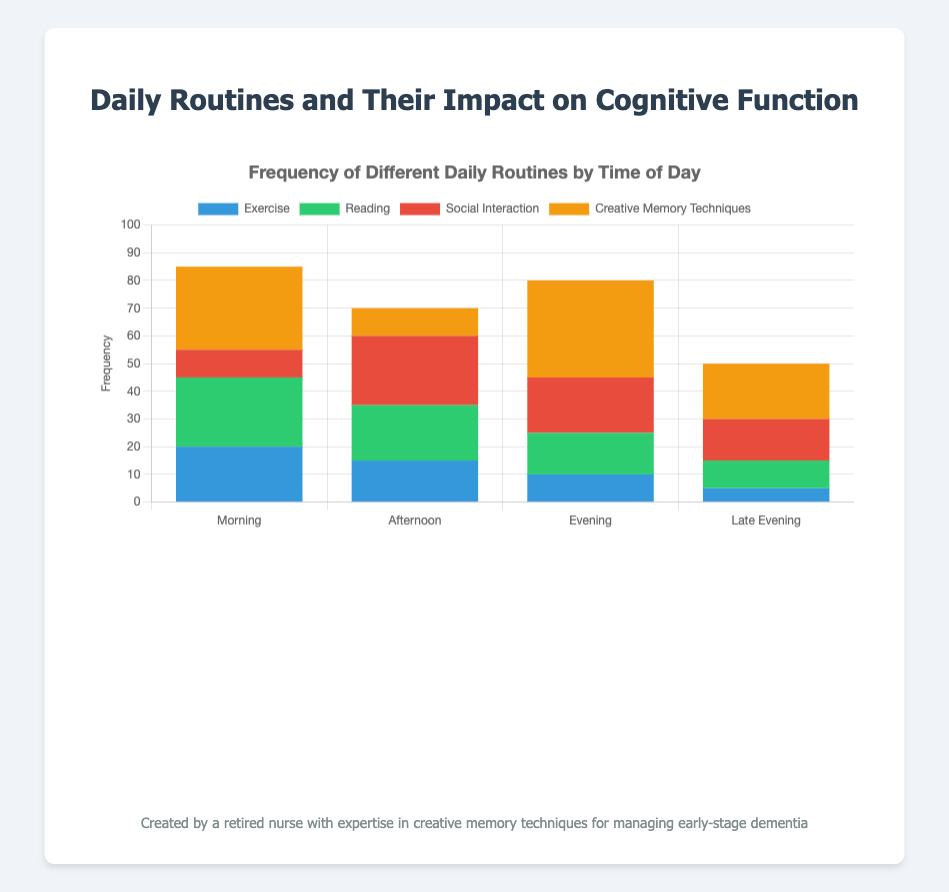What time of day had the highest frequency of social interaction? To determine this, observe the heights of the red bars that represent social interaction across different times of the day. The red bar is tallest for the "Afternoon" category, indicating the highest frequency of social interaction.
Answer: Afternoon What is the total frequency of daily routines in the Morning? Sum the frequencies of Exercise, Reading, Social Interaction, and Creative Memory Techniques for the Morning: 20 + 25 + 10 + 30 = 85.
Answer: 85 Which activity shows the greatest increase in frequency in the Evening compared to the Afternoon? Compare the frequencies of each activity between Afternoon and Evening. Exercise: 15 -> 10 (decrease), Reading: 20 -> 15 (decrease), Social Interaction: 25 -> 20 (decrease), Creative Memory Techniques: 10 -> 35 (increase). Creative Memory Techniques shows the greatest increase.
Answer: Creative Memory Techniques How does the cognitive function increase (%) in the Late Evening compare to the Morning? Compare the cognitive function increase percentages: Late Evening (5%), Morning (15%). The increase in the Morning is greater than in the Late Evening.
Answer: Morning is greater During which time of day does the combination of Social Interaction and Creative Memory Techniques have the highest frequency? Calculate the combined frequency of Social Interaction and Creative Memory Techniques for each time of day: Morning (10 + 30 = 40), Afternoon (25 + 10 = 35), Evening (20 + 35 = 55), Late Evening (15 + 20 = 35). The combined frequency is highest in the Evening (55).
Answer: Evening What is the sum of all activity frequencies in the Evening? Add the frequencies of all activities in the Evening: Exercise (10) + Reading (15) + Social Interaction (20) + Creative Memory Techniques (35). The sum is 10 + 15 + 20 + 35 = 80.
Answer: 80 Which time of day had the lowest frequency of exercise? To determine this, observe the blue bars that represent exercise frequencies. The blue bar is shortest for Late Evening, indicating the lowest frequency of exercise.
Answer: Late Evening How much higher is the frequency of Reading in the Morning compared to the Evening? Compare the frequencies of Reading: Morning (25) and Evening (15). Calculate the difference: 25 - 15 = 10.
Answer: 10 Which activities were least frequent in the Afternoon? In the Afternoon, the smallest bars represent the least frequent activities. The bars for Creative Memory Techniques are the shortest, indicating it has the lowest frequency.
Answer: Creative Memory Techniques What is the average cognitive function increase across all times of day? Sum the cognitive function increases and divide by the number of time categories: (15 + 10 + 20 + 5) / 4 = 50 / 4 = 12.5.
Answer: 12.5 